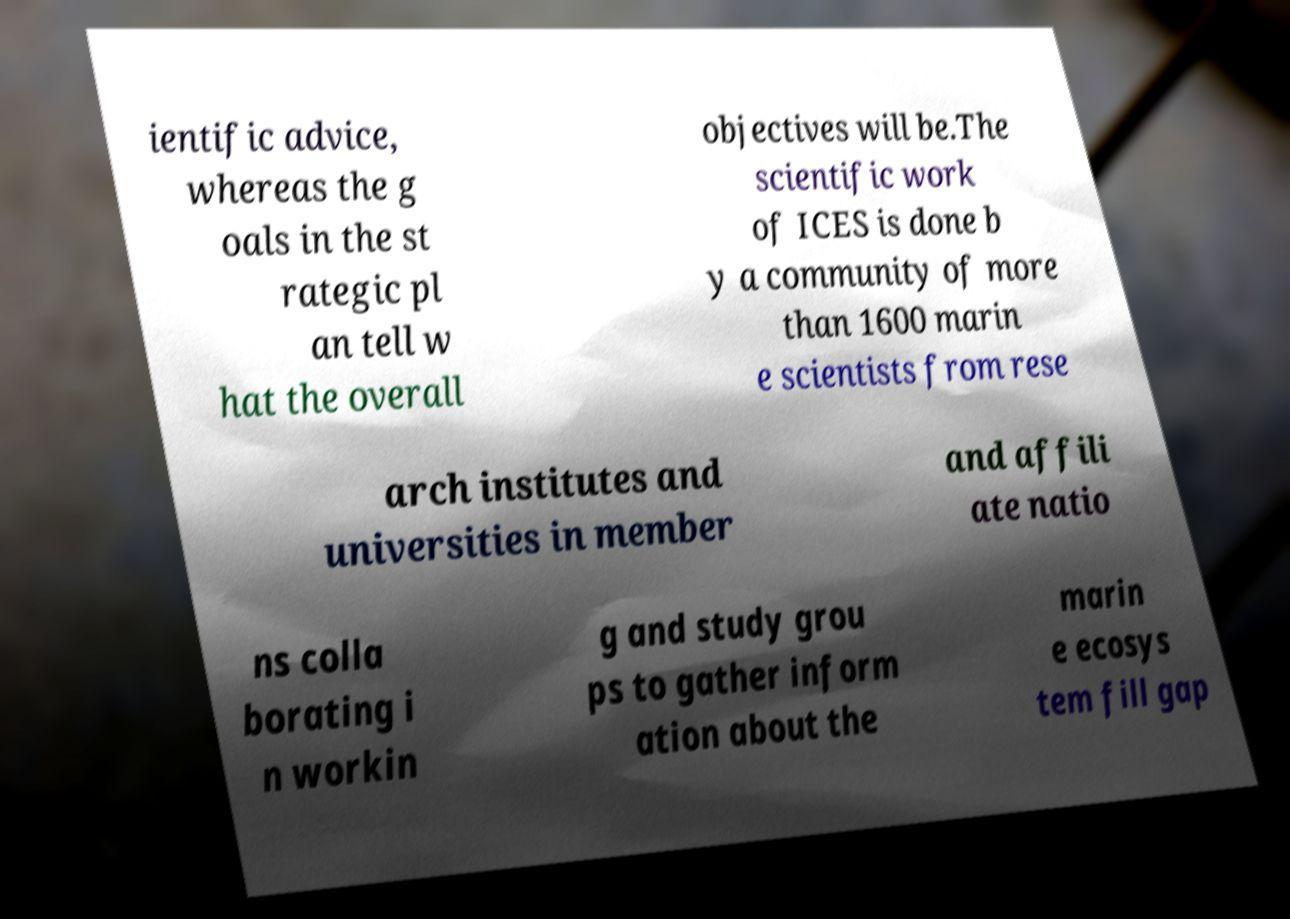I need the written content from this picture converted into text. Can you do that? ientific advice, whereas the g oals in the st rategic pl an tell w hat the overall objectives will be.The scientific work of ICES is done b y a community of more than 1600 marin e scientists from rese arch institutes and universities in member and affili ate natio ns colla borating i n workin g and study grou ps to gather inform ation about the marin e ecosys tem fill gap 